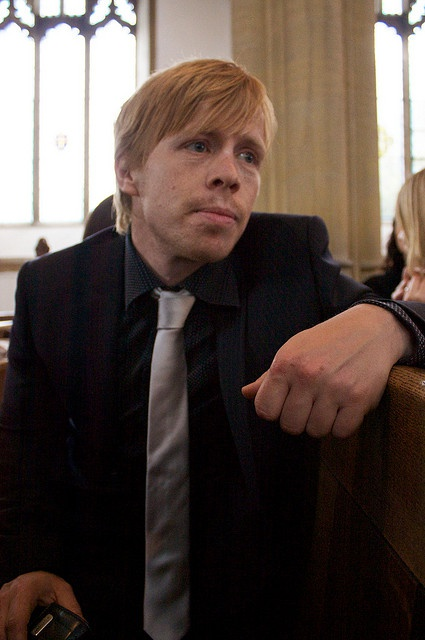Describe the objects in this image and their specific colors. I can see people in violet, black, brown, and maroon tones, tie in violet, black, and gray tones, people in violet, gray, tan, and brown tones, and cell phone in violet, black, maroon, and darkgray tones in this image. 